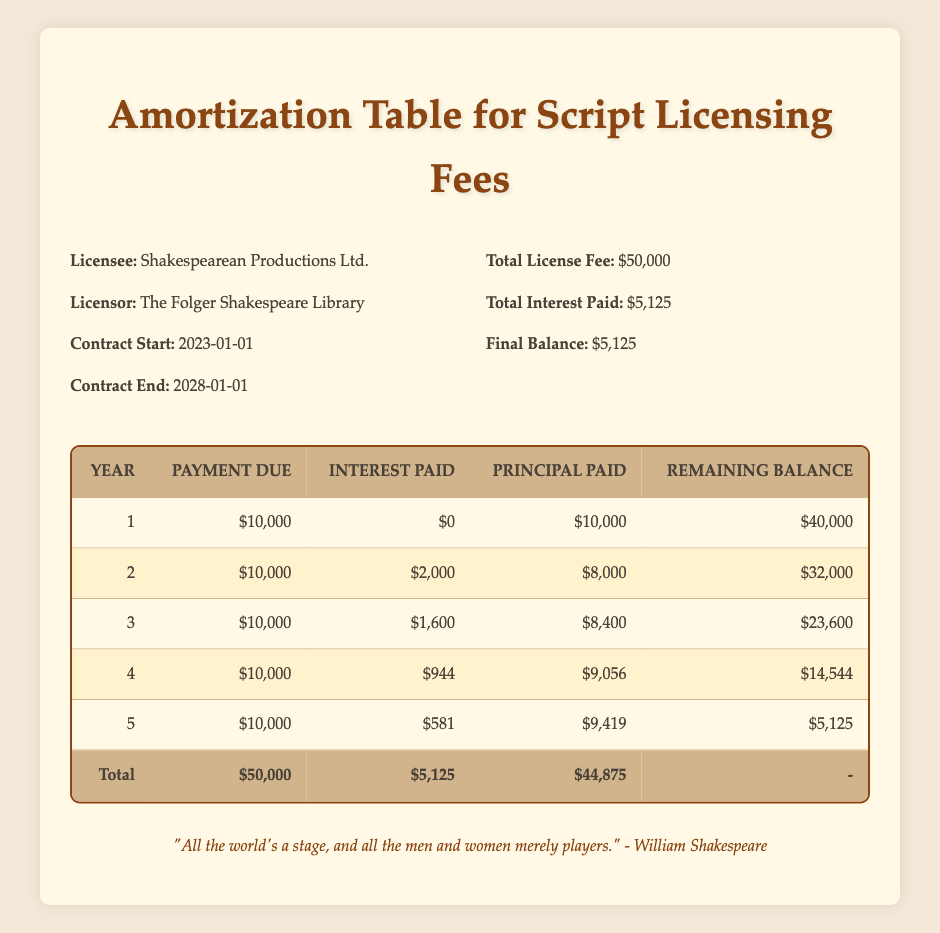What is the total license fee for the script? The table states that the total license fee is $50,000.
Answer: 50000 How much was the interest paid in the second year? From the table, the interest paid in the second year is listed as $2,000.
Answer: 2000 What is the remaining balance after the fourth payment? According to the table, after the fourth payment, the remaining balance is $14,544.
Answer: 14544 How much total principal was paid over the five years? To find the total principal paid, sum the principal paid each year: 10000 + 8000 + 8400 + 9056 + 9419 = 44,875.
Answer: 44875 Is the interest paid in Year 5 less than in Year 4? Comparing the interest paid: Year 4 has $944 and Year 5 has $581, thus Year 5's interest is indeed less than Year 4's.
Answer: Yes What was the highest annual payment due in the amortization schedule? Each year has a payment due of $10,000, so the highest annual payment due is $10,000.
Answer: 10000 If the payment schedule continues as is, what will the remaining balance be after the fifth payment? The table states the remaining balance after the fifth payment is $5,125, indicating this is the balance left after all scheduled payments.
Answer: 5125 What is the average interest paid over the five years? The total interest paid is $5,125 for five years, thus the average interest per year is 5125 / 5 = 1,025.
Answer: 1025 How much did the principal payment increase from Year 2 to Year 3? The principal paid in Year 2 is $8,000 and in Year 3 is $8,400, so the increase is 8400 - 8000 = $400.
Answer: 400 